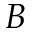Convert formula to latex. <formula><loc_0><loc_0><loc_500><loc_500>B</formula> 